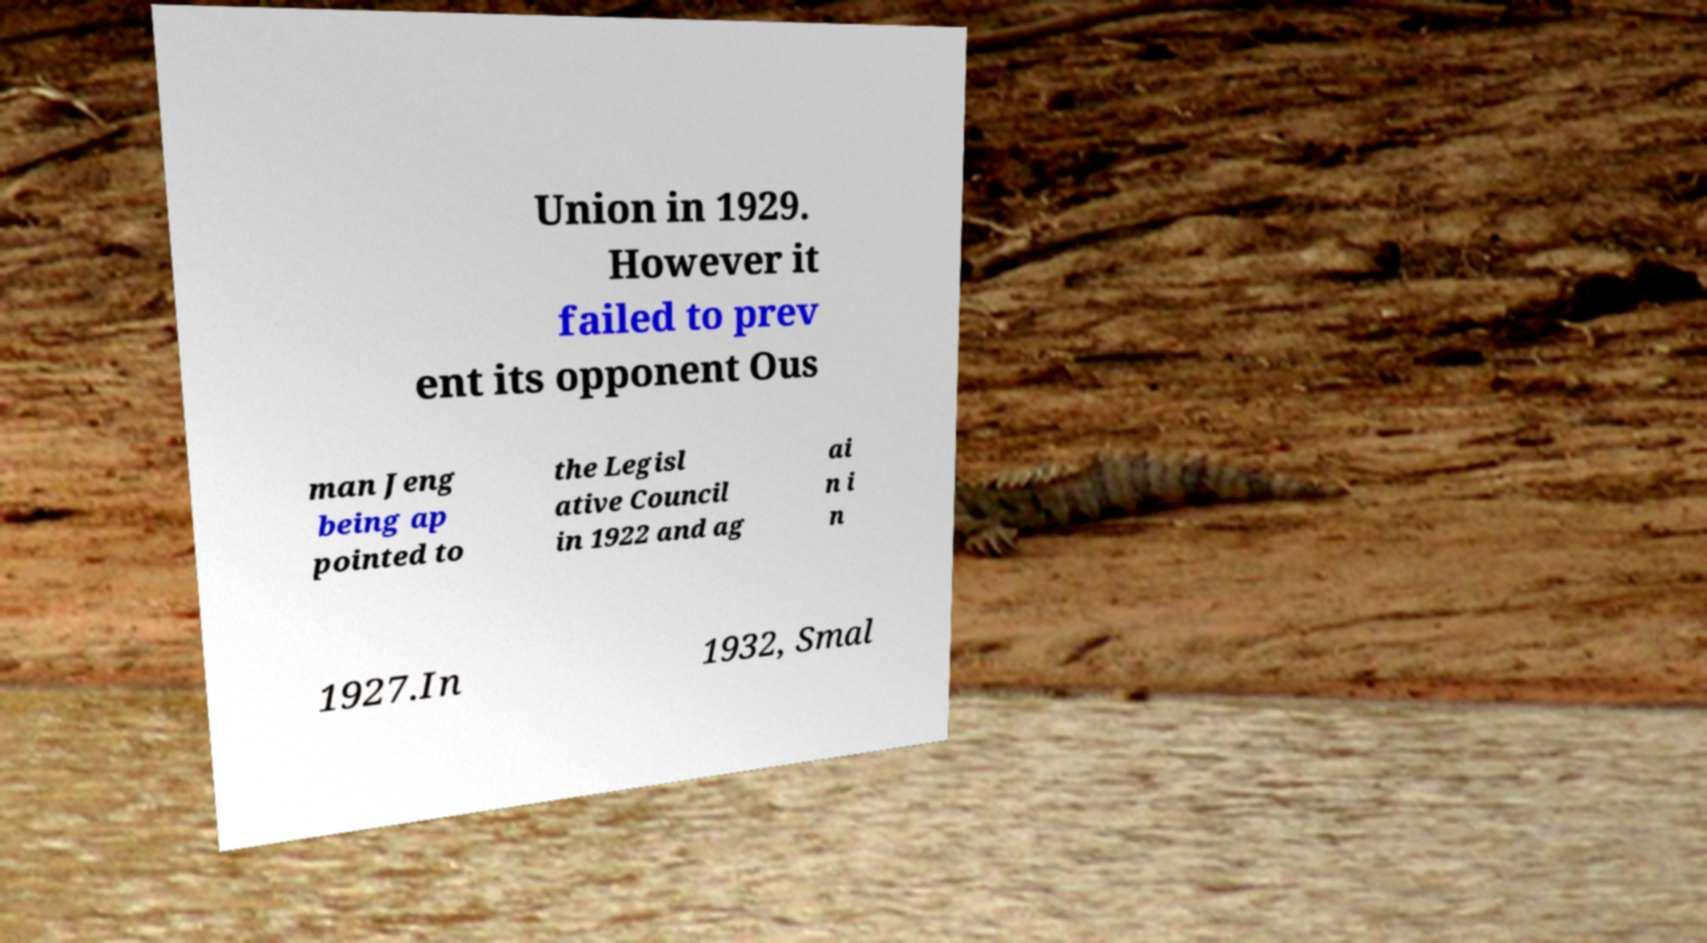Could you assist in decoding the text presented in this image and type it out clearly? Union in 1929. However it failed to prev ent its opponent Ous man Jeng being ap pointed to the Legisl ative Council in 1922 and ag ai n i n 1927.In 1932, Smal 